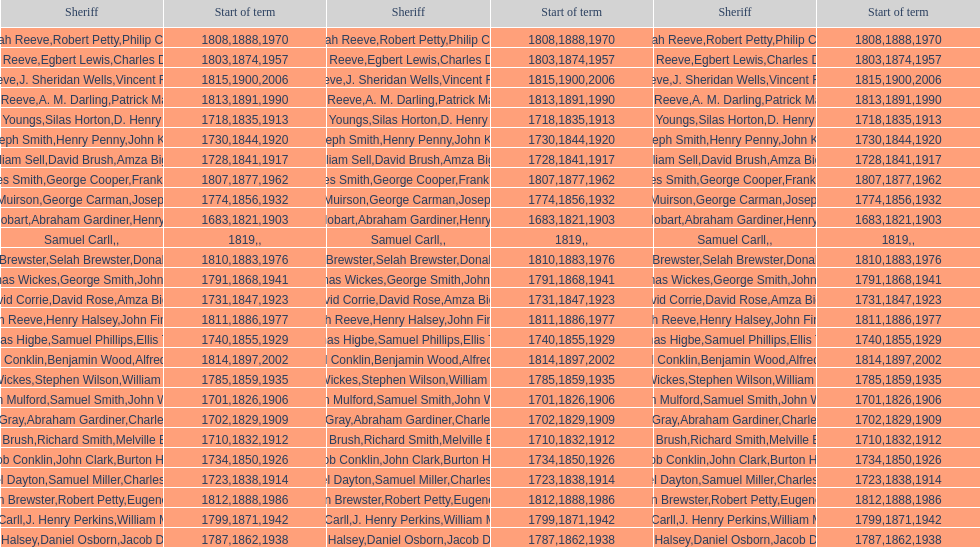Parse the full table. {'header': ['Sheriff', 'Start of term', 'Sheriff', 'Start of term', 'Sheriff', 'Start of term'], 'rows': [['Josiah Reeve', '1808', 'Robert Petty', '1888', 'Philip Corso', '1970'], ['Josiah Reeve', '1803', 'Egbert Lewis', '1874', 'Charles Dominy', '1957'], ['Josiah Reeve', '1815', 'J. Sheridan Wells', '1900', 'Vincent F. DeMarco', '2006'], ['Josiah Reeve', '1813', 'A. M. Darling', '1891', 'Patrick Mahoney', '1990'], ['Daniel Youngs', '1718', 'Silas Horton', '1835', 'D. Henry Brown', '1913'], ['Joseph Smith', '1730', 'Henry Penny', '1844', 'John Kelly', '1920'], ['William Sell', '1728', 'David Brush', '1841', 'Amza Biggs', '1917'], ['Phinaes Smith', '1807', 'George Cooper', '1877', 'Frank Gross', '1962'], ['James Muirson', '1774', 'George Carman', '1856', 'Joseph Warta', '1932'], ['Josiah Hobart', '1683', 'Abraham Gardiner', '1821', 'Henry Preston', '1903'], ['Samuel Carll', '1819', '', '', '', ''], ['Benjamin Brewster', '1810', 'Selah Brewster', '1883', 'Donald Dilworth', '1976'], ['Thomas Wickes', '1791', 'George Smith', '1868', 'John Levy', '1941'], ['David Corrie', '1731', 'David Rose', '1847', 'Amza Biggs', '1923'], ['Josiah Reeve', '1811', 'Henry Halsey', '1886', 'John Finnerty', '1977'], ['Thomas Higbe', '1740', 'Samuel Phillips', '1855', 'Ellis Taylor', '1929'], ['Nathaniel Conklin', '1814', 'Benjamin Wood', '1897', 'Alfred C. Tisch', '2002'], ['Thomas Wickes', '1785', 'Stephen Wilson', '1859', 'William McCollom', '1935'], ['John Mulford', '1701', 'Samuel Smith', '1826', 'John Wells', '1906'], ['Hugh Gray', '1702', 'Abraham Gardiner', '1829', 'Charles Platt', '1909'], ['John Brush', '1710', 'Richard Smith', '1832', 'Melville Brush', '1912'], ['Jacob Conklin', '1734', 'John Clark', '1850', 'Burton Howe', '1926'], ['Samuel Dayton', '1723', 'Samuel Miller', '1838', "Charles O'Dell", '1914'], ['Benjamin Brewster', '1812', 'Robert Petty', '1888', 'Eugene Dooley', '1986'], ['Phinaes Carll', '1799', 'J. Henry Perkins', '1871', 'William McCollom', '1942'], ['Silas Halsey', '1787', 'Daniel Osborn', '1862', 'Jacob Dreyer', '1938']]} What is the number of sheriff's with the last name smith? 5. 